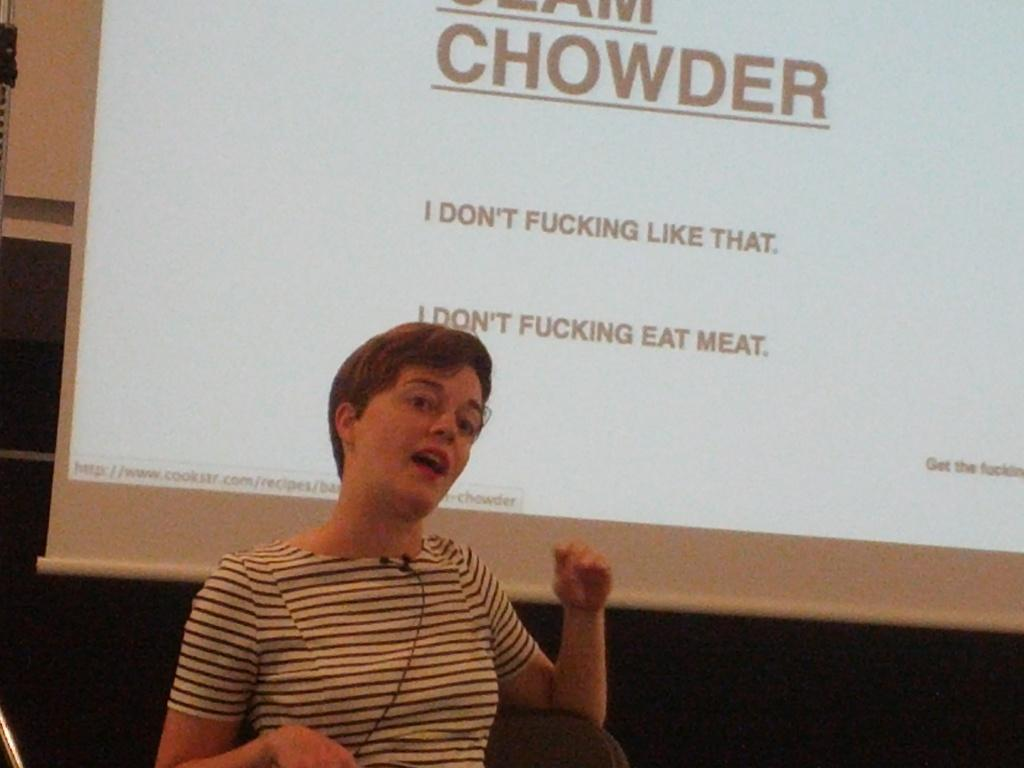What is the person in the image doing? The person is sitting on a chair and speaking. What can be seen on the screen in the image? There is a display on the screen in the image. What type of control is the person using to manipulate the pail in the image? There is no pail present in the image, so it is not possible to determine what type of control might be used to manipulate it. 